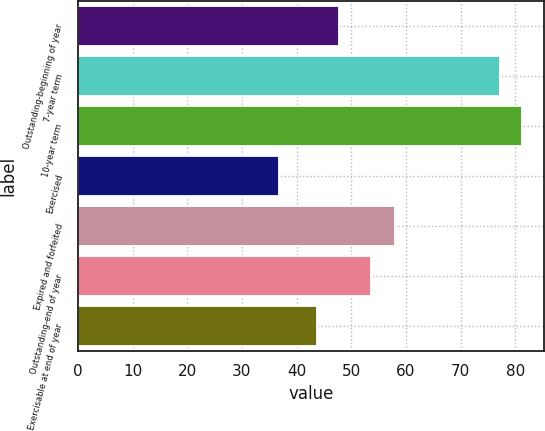<chart> <loc_0><loc_0><loc_500><loc_500><bar_chart><fcel>Outstanding-beginning of year<fcel>7-year term<fcel>10-year term<fcel>Exercised<fcel>Expired and forfeited<fcel>Outstanding-end of year<fcel>Exercisable at end of year<nl><fcel>47.83<fcel>77.19<fcel>81.23<fcel>36.84<fcel>57.94<fcel>53.59<fcel>43.79<nl></chart> 